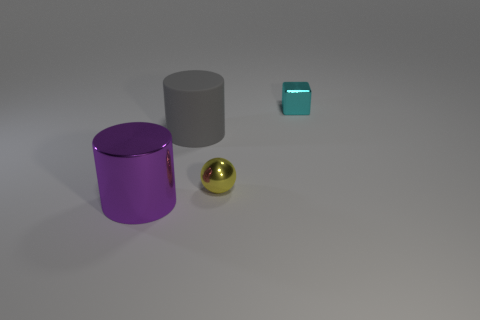How do the colors of the objects interact with one another aesthetically? In the image, the color palette is quite limited but thoughtfully composed. The bold purple of the larger cylinder adds vibrancy and is aesthetically balanced by the neutral gray of its counterpart. The turquoise block, though small, gives a pop of cool color that complements the purple, while the golden sphere introduces a warm tone that contrasts nicely with the cooler hues. Overall, the interplay of colors is harmonious and pleasing to the eye, with each object unifying to contribute to the image's overall aesthetic appeal. 